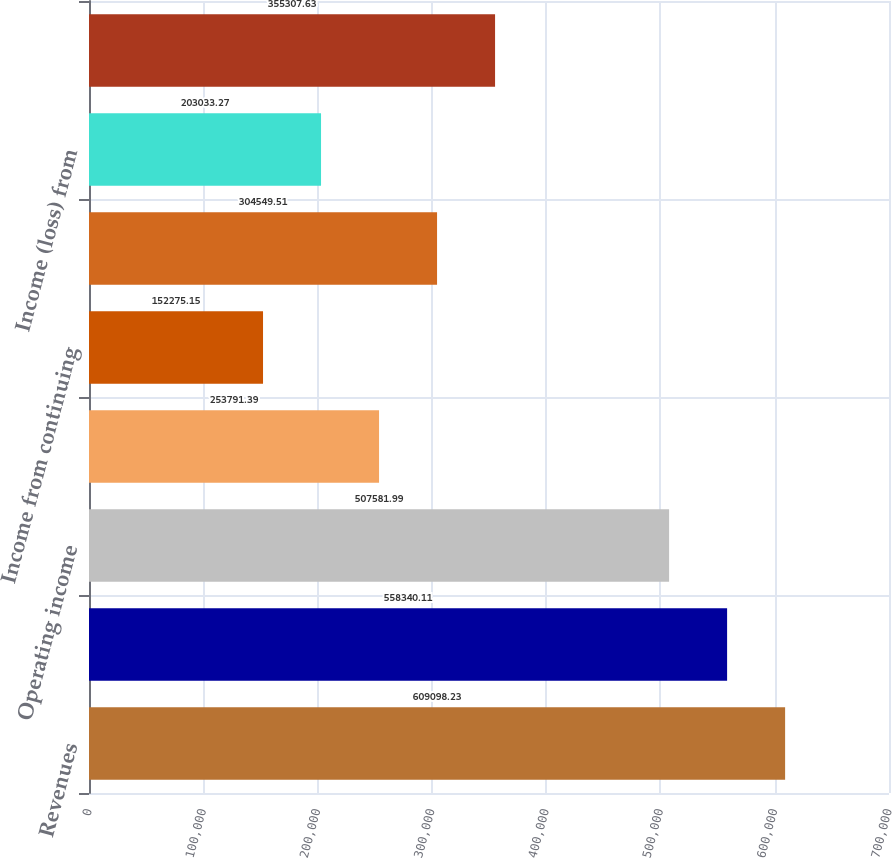Convert chart to OTSL. <chart><loc_0><loc_0><loc_500><loc_500><bar_chart><fcel>Revenues<fcel>Operating expenses<fcel>Operating income<fcel>Interest expense net<fcel>Income from continuing<fcel>Provision for income taxes<fcel>Income (loss) from<fcel>Net income<nl><fcel>609098<fcel>558340<fcel>507582<fcel>253791<fcel>152275<fcel>304550<fcel>203033<fcel>355308<nl></chart> 